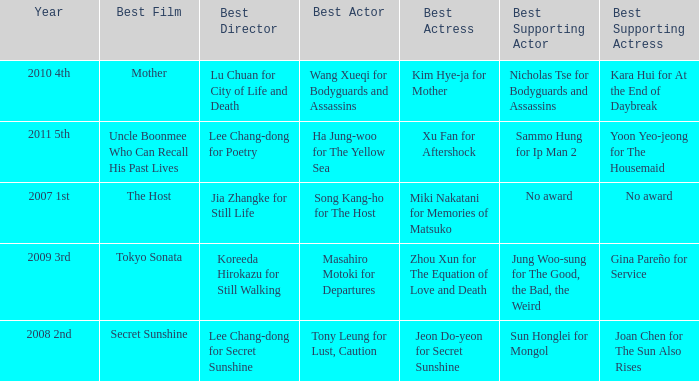Name the year for sammo hung for ip man 2 2011 5th. 